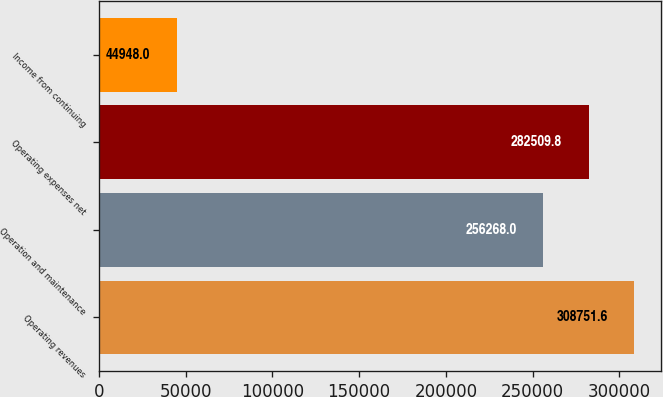Convert chart to OTSL. <chart><loc_0><loc_0><loc_500><loc_500><bar_chart><fcel>Operating revenues<fcel>Operation and maintenance<fcel>Operating expenses net<fcel>Income from continuing<nl><fcel>308752<fcel>256268<fcel>282510<fcel>44948<nl></chart> 